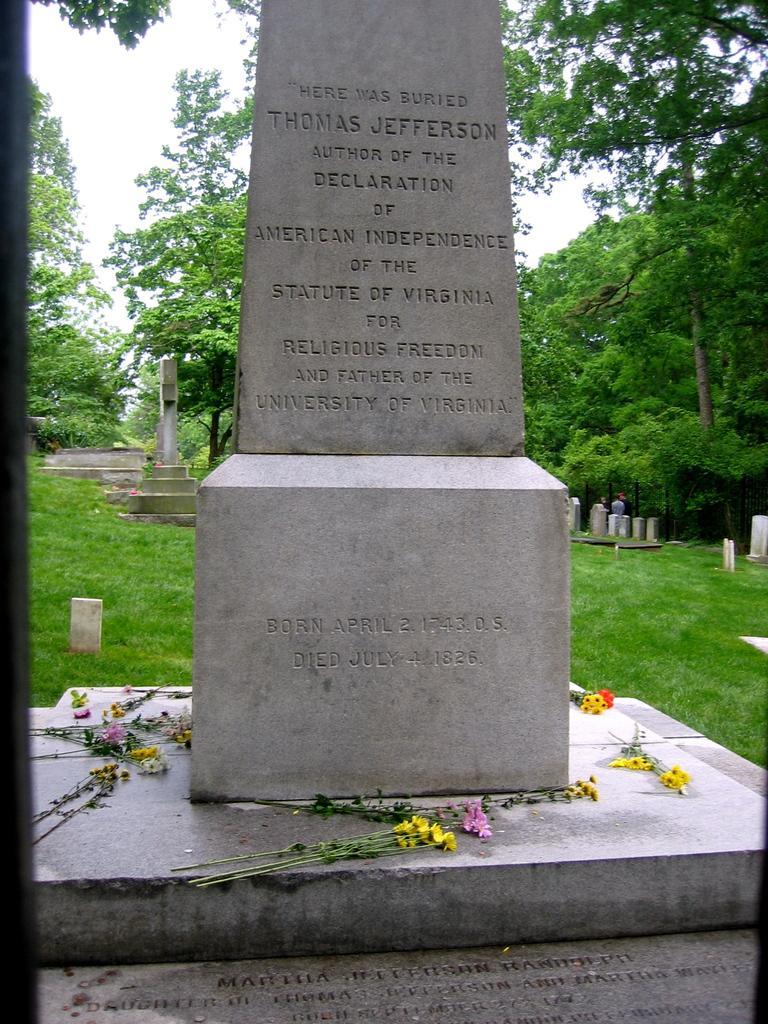Please provide a concise description of this image. This picture is clicked outside. In the foreground we can see the grave on which something flowers are placed and in the background we can see the green grass, many number of graves, sky and trees. 